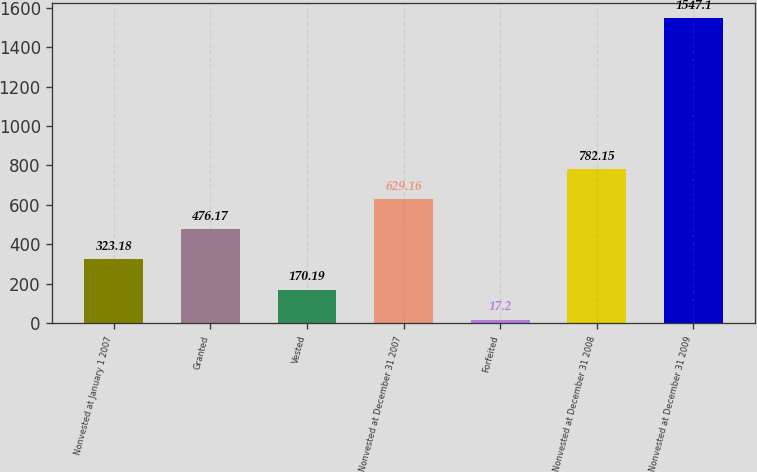<chart> <loc_0><loc_0><loc_500><loc_500><bar_chart><fcel>Nonvested at January 1 2007<fcel>Granted<fcel>Vested<fcel>Nonvested at December 31 2007<fcel>Forfeited<fcel>Nonvested at December 31 2008<fcel>Nonvested at December 31 2009<nl><fcel>323.18<fcel>476.17<fcel>170.19<fcel>629.16<fcel>17.2<fcel>782.15<fcel>1547.1<nl></chart> 